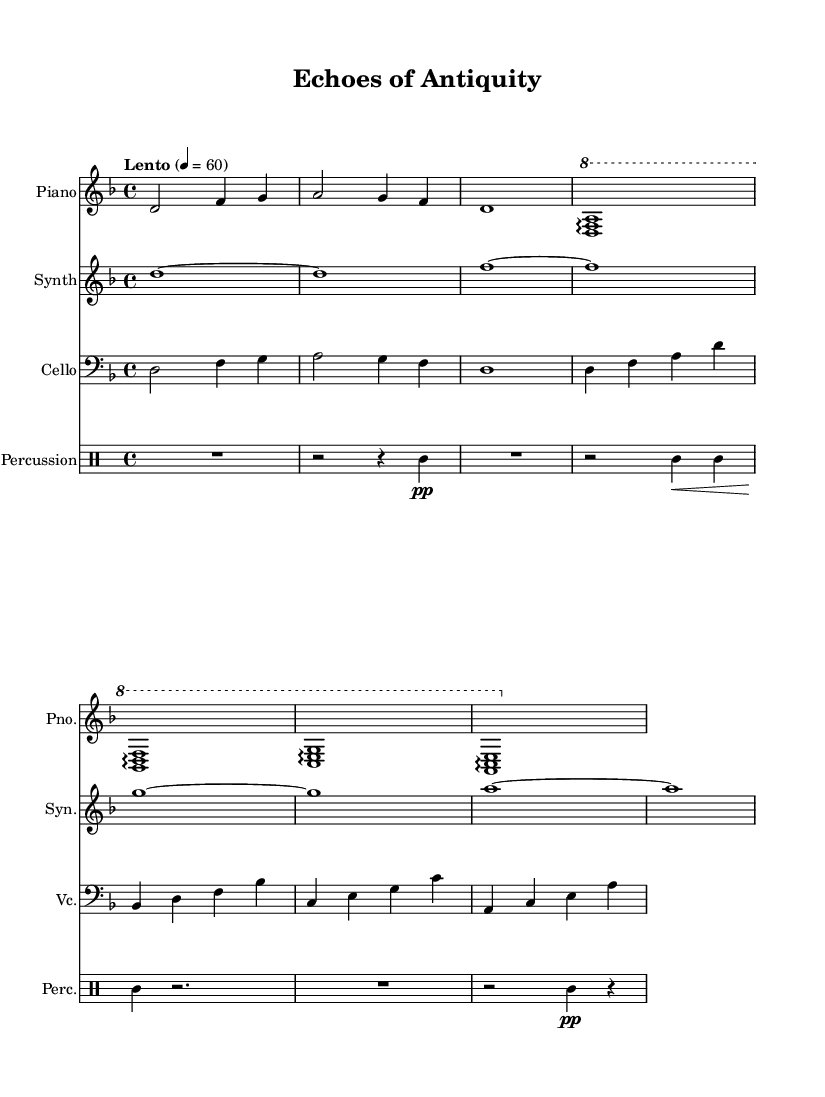What is the key signature of this music? The key signature indicated is D minor, which consists of one flat (B flat), shown in the beginning of the score.
Answer: D minor What is the time signature of this music? The time signature is 4/4, which is represented at the beginning of the score and denotes four beats per measure.
Answer: 4/4 What is the tempo marking of this piece? The tempo marking is "Lento," which indicates a slow speed, along with a metronome marking of 60 beats per minute.
Answer: Lento How many instruments are featured in this score? There are four distinct instruments shown in the score: Piano, Synth, Cello, and Percussion, which are listed at the start of each staff.
Answer: Four What is the dynamic marking for the percussion part? The percussion part has a dynamic marking of "pp," indicating it should be played very softly, as seen in the relevant measure near the middle of its staff.
Answer: pp What type of harmonic textures are used in the piano part? The piano part features arpeggios, as indicated by the arpeggio markings seen throughout several measures of the score where chords are connected.
Answer: Arpeggios How does the cello part create musical movement? The cello part employs a combination of half and whole notes, alternating between lower and higher pitches, which creates a sense of flowing movement in the music.
Answer: Flowing movement 